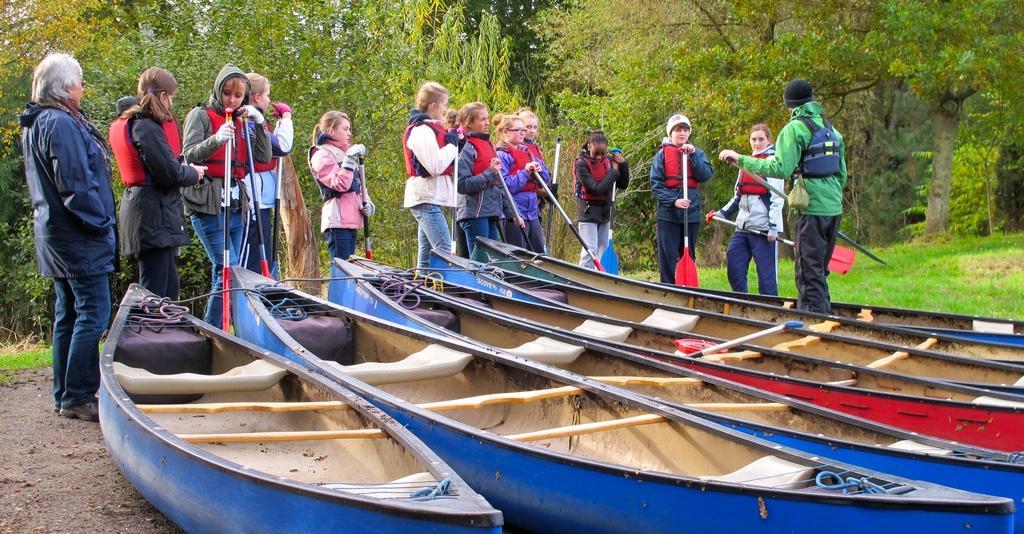How would you summarize this image in a sentence or two? In the middle these are the boats which are in blue color and many girls are standing. They were life jackets, behind them there are green color trees. 